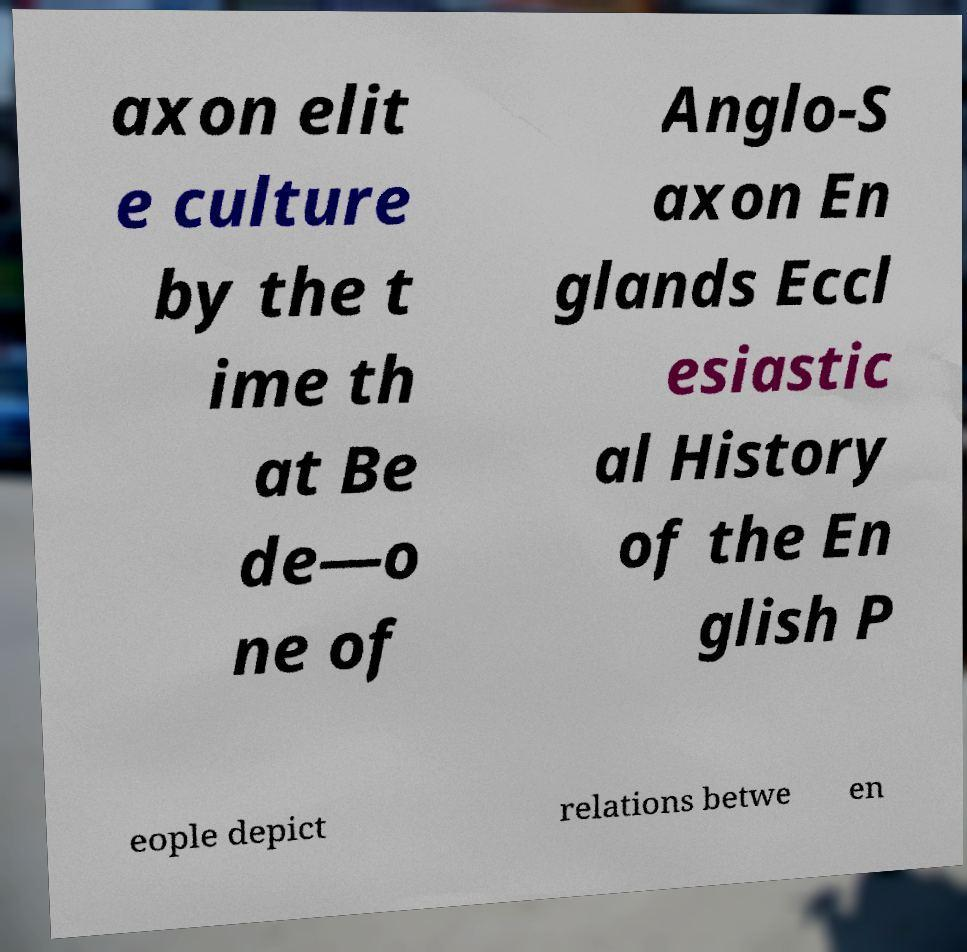Can you read and provide the text displayed in the image?This photo seems to have some interesting text. Can you extract and type it out for me? axon elit e culture by the t ime th at Be de—o ne of Anglo-S axon En glands Eccl esiastic al History of the En glish P eople depict relations betwe en 